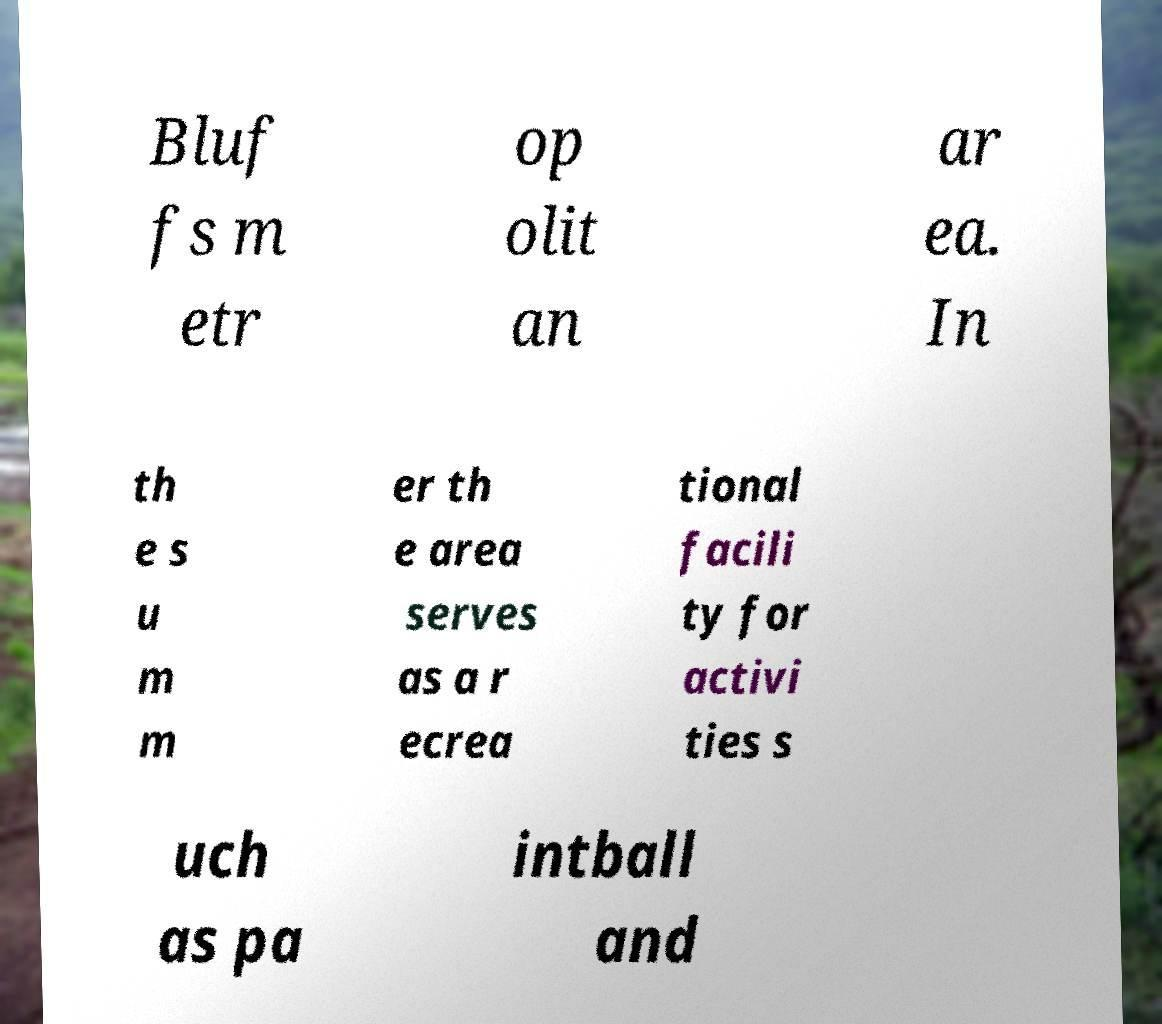What messages or text are displayed in this image? I need them in a readable, typed format. Bluf fs m etr op olit an ar ea. In th e s u m m er th e area serves as a r ecrea tional facili ty for activi ties s uch as pa intball and 